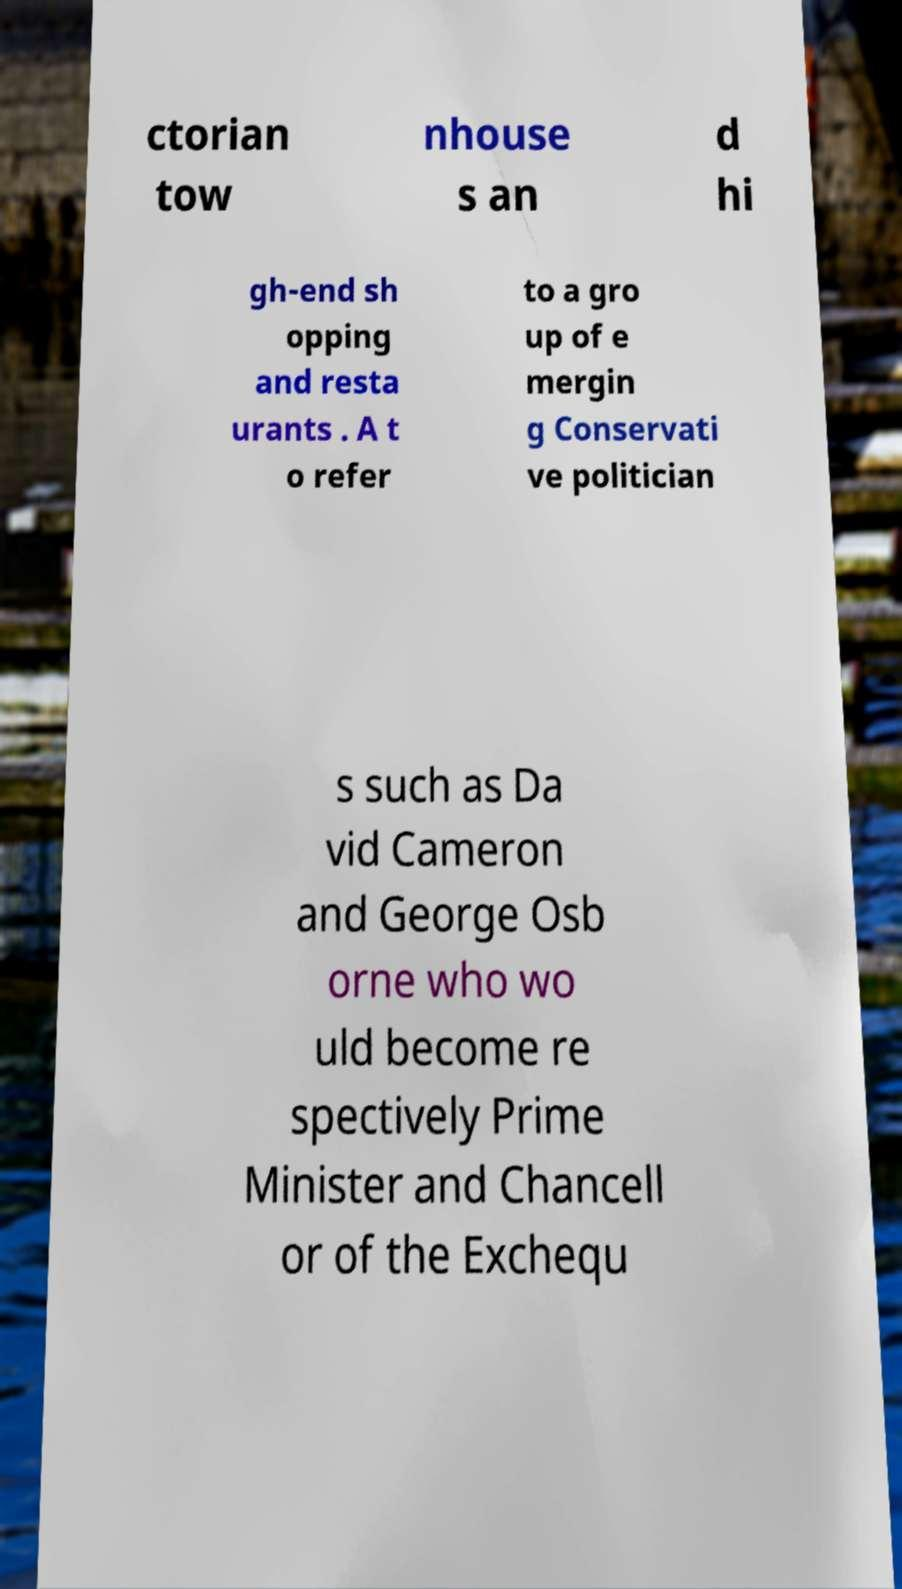For documentation purposes, I need the text within this image transcribed. Could you provide that? ctorian tow nhouse s an d hi gh-end sh opping and resta urants . A t o refer to a gro up of e mergin g Conservati ve politician s such as Da vid Cameron and George Osb orne who wo uld become re spectively Prime Minister and Chancell or of the Exchequ 